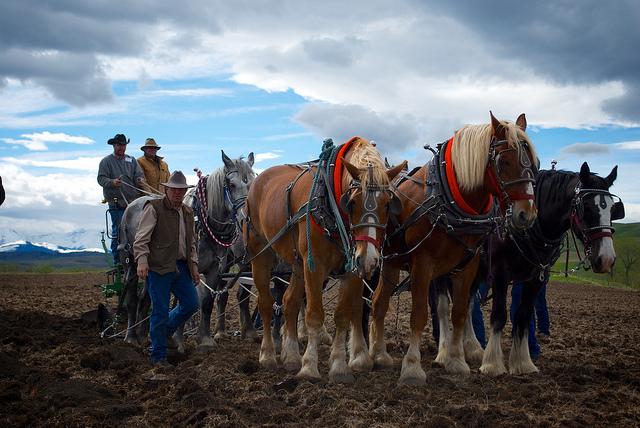What is on the horse on the right?
Be succinct. Saddle. Is everyone wearing a hat?
Give a very brief answer. Yes. Why are the animals marked with orange?
Be succinct. Horses. What kinds of animals are those?
Quick response, please. Horses. How many horses are pictured?
Keep it brief. 4. Are the horses plush?
Short answer required. No. Are these draft horses?
Concise answer only. Yes. Are these horses going to a celebration?
Be succinct. No. Is there a cobblestone street?
Short answer required. No. What is the color of the horse?
Keep it brief. Brown. What are these men's profession?
Quick response, please. Farmers. What color is the man's hat?
Quick response, please. Gray. What are the people doing?
Short answer required. Plowing. What type of animals are these?
Be succinct. Horses. What is on the horse?
Keep it brief. Harness. What are the horses pulling?
Concise answer only. Plow. What is the horse made of?
Give a very brief answer. Dna. Was this picture taken at an animal preserve?
Write a very short answer. No. What color stands out the most?
Write a very short answer. Red. Is the animal male or female?
Answer briefly. Female. What kind of animal are they riding?
Give a very brief answer. Horses. Are the horses all different colors?
Be succinct. Yes. How many horses are there?
Quick response, please. 4. Are there any white horses?
Be succinct. No. Do the black horses legs look short?
Write a very short answer. No. What tool do many people use other than this to till the ground?
Give a very brief answer. Tractor. What are these horses pulling?
Keep it brief. Plow. Is this part of a parade?
Quick response, please. No. 